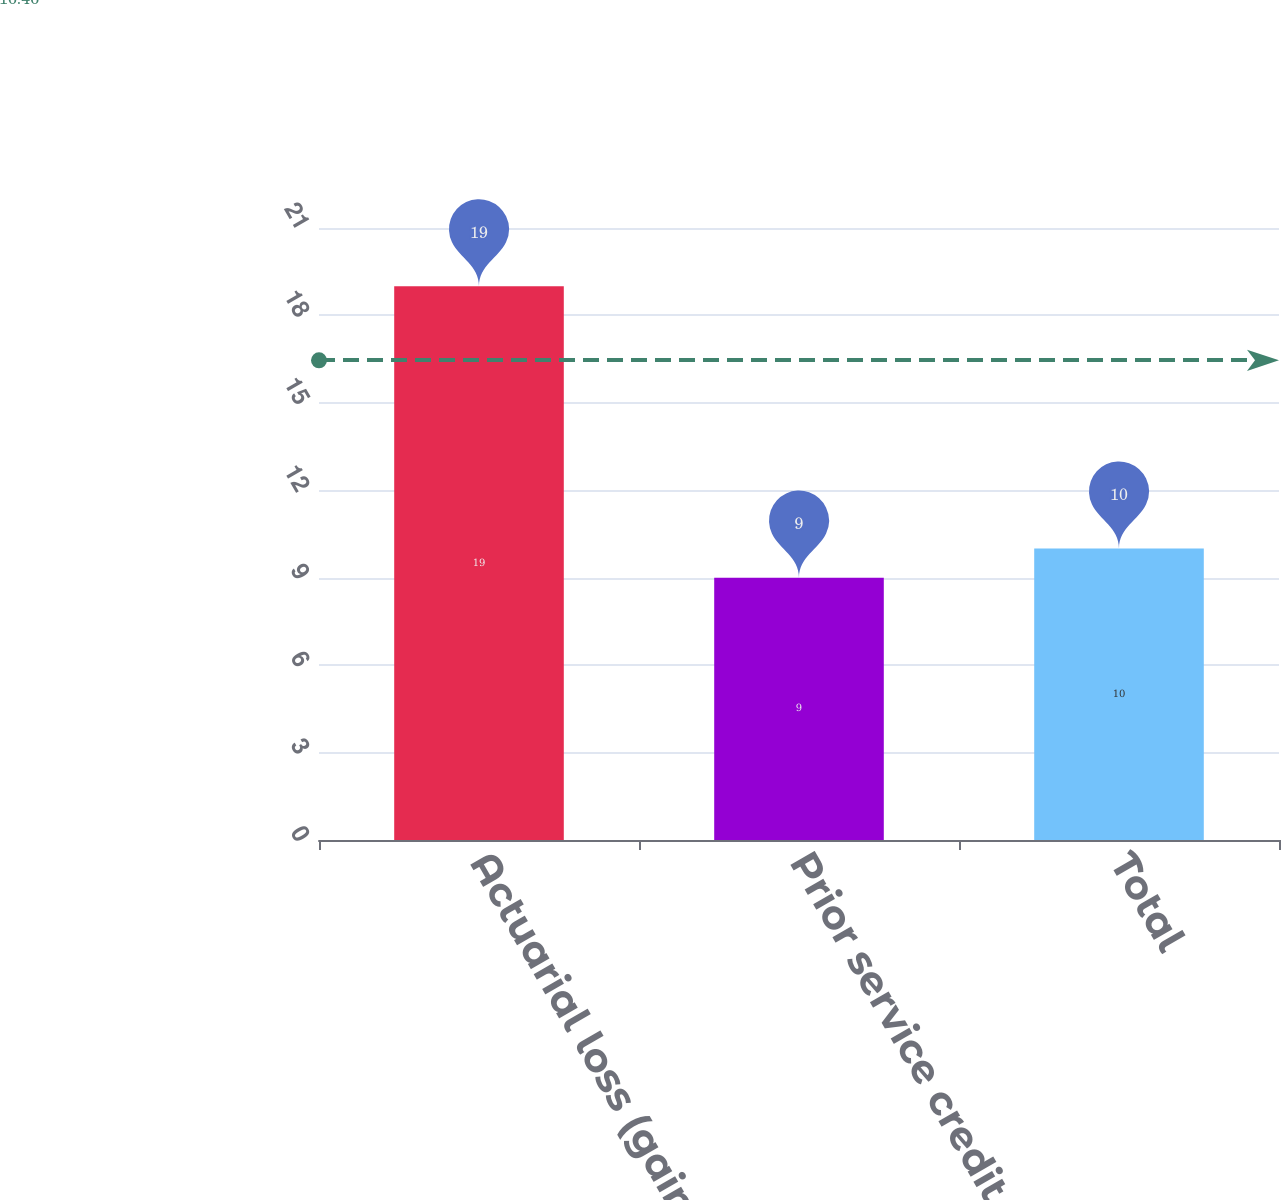<chart> <loc_0><loc_0><loc_500><loc_500><bar_chart><fcel>Actuarial loss (gain)<fcel>Prior service credit<fcel>Total<nl><fcel>19<fcel>9<fcel>10<nl></chart> 